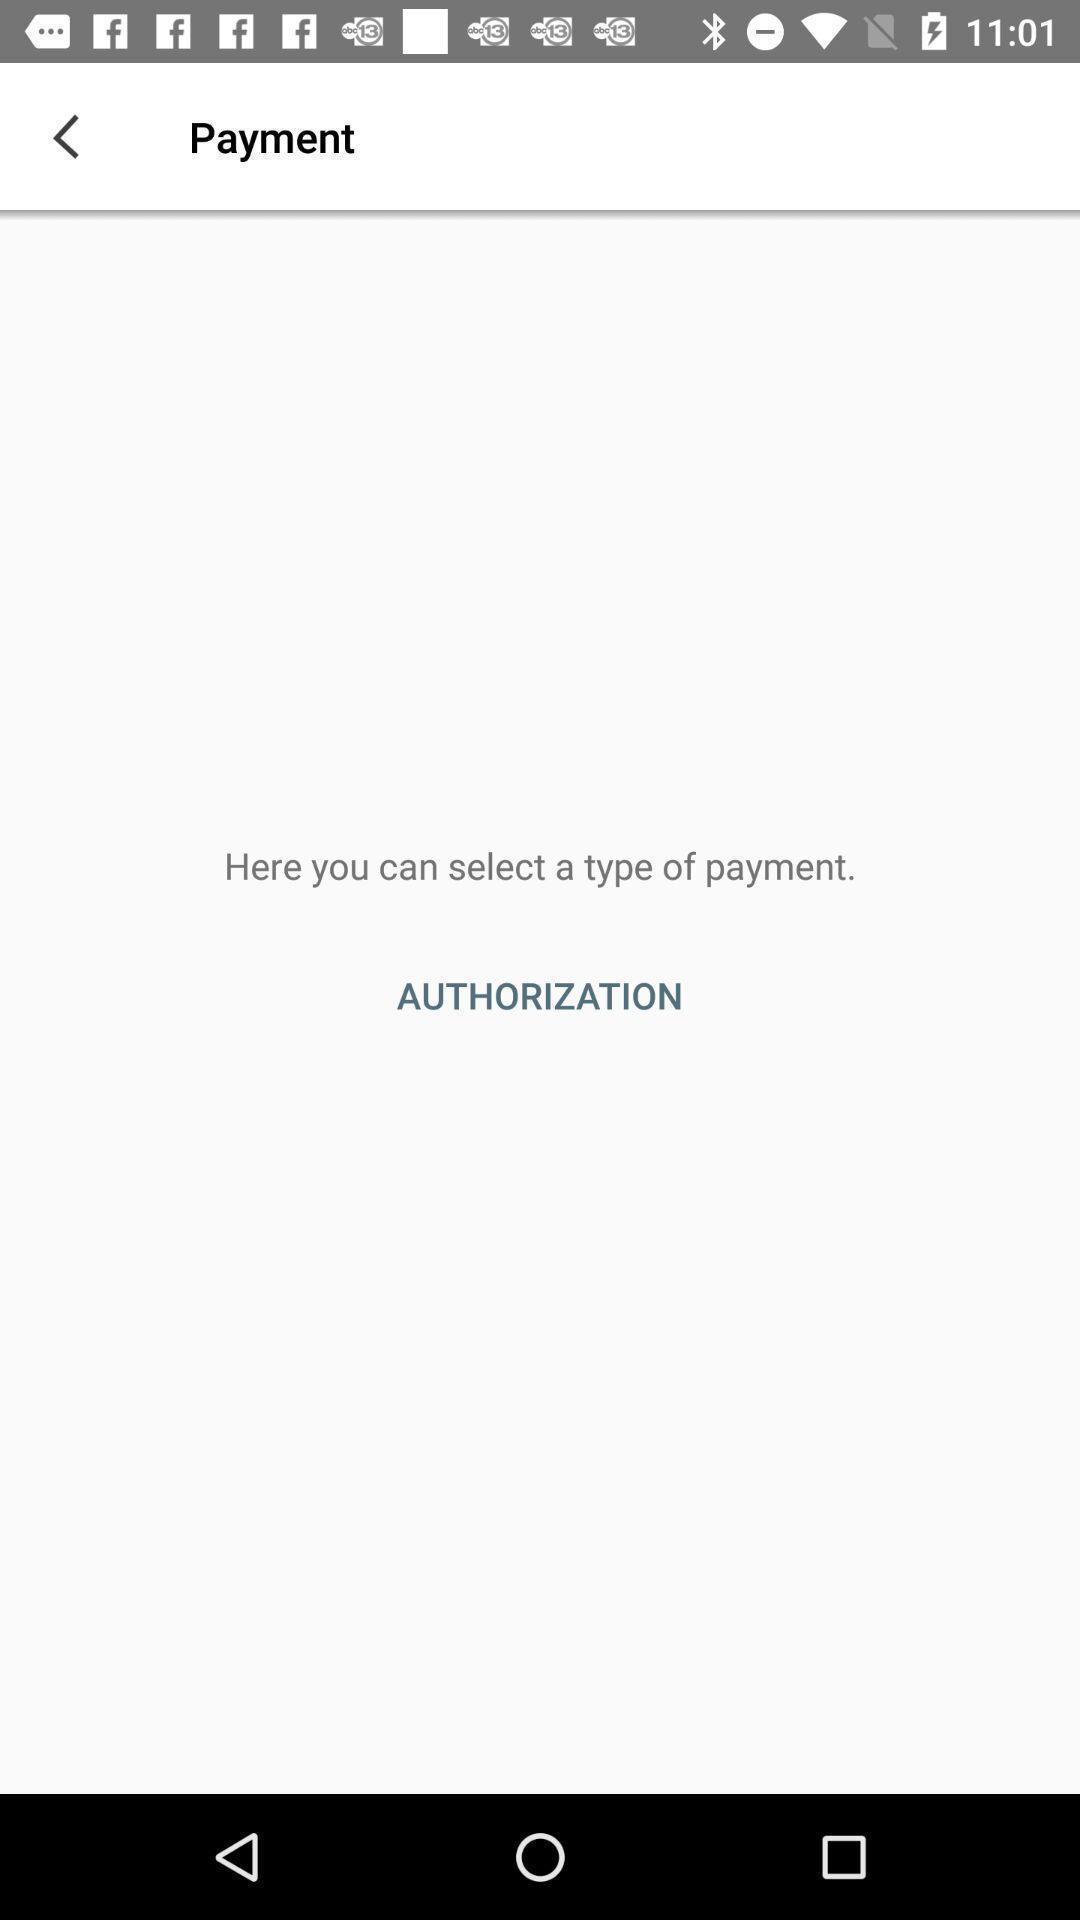Tell me what you see in this picture. Screen showing payment page. 